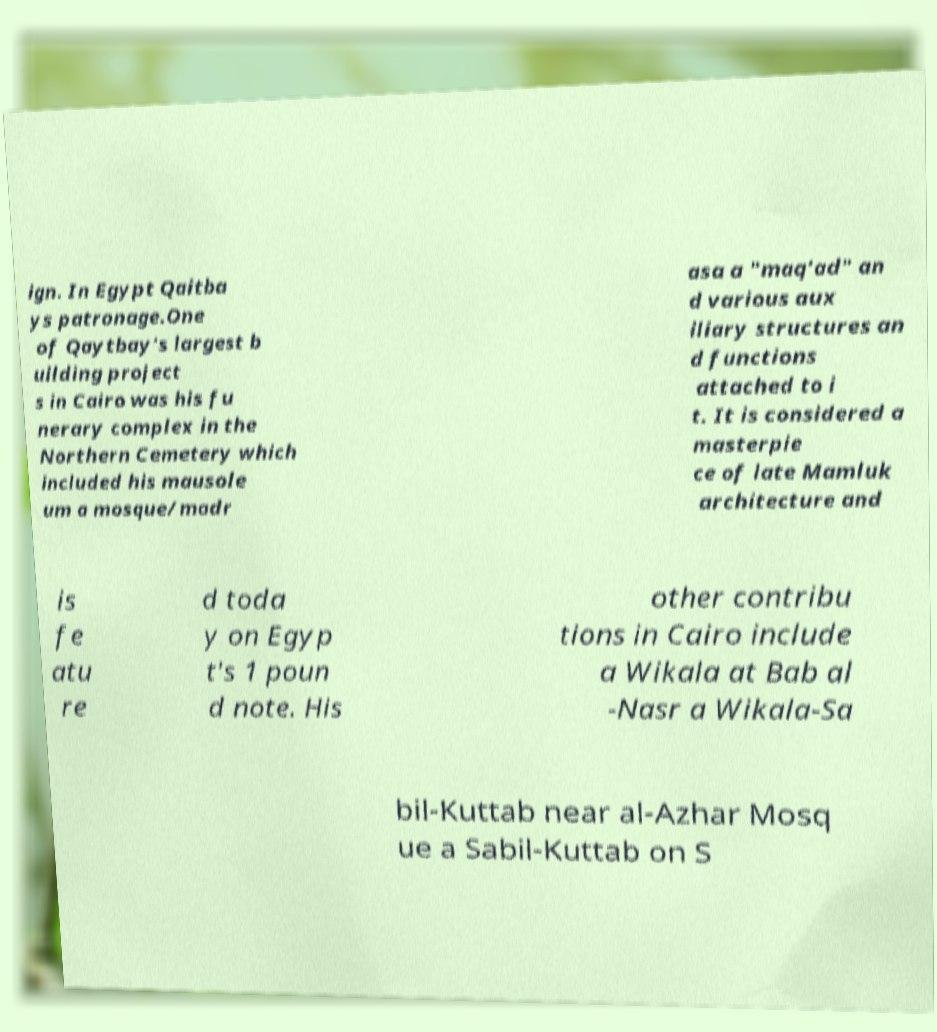Please identify and transcribe the text found in this image. ign. In Egypt Qaitba ys patronage.One of Qaytbay's largest b uilding project s in Cairo was his fu nerary complex in the Northern Cemetery which included his mausole um a mosque/madr asa a "maq'ad" an d various aux iliary structures an d functions attached to i t. It is considered a masterpie ce of late Mamluk architecture and is fe atu re d toda y on Egyp t's 1 poun d note. His other contribu tions in Cairo include a Wikala at Bab al -Nasr a Wikala-Sa bil-Kuttab near al-Azhar Mosq ue a Sabil-Kuttab on S 